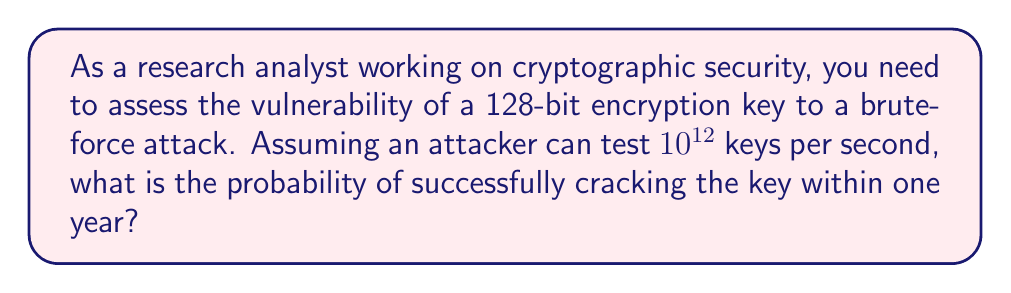Solve this math problem. To solve this problem, we'll follow these steps:

1) First, calculate the total number of possible 128-bit keys:
   $N = 2^{128}$

2) Calculate the number of keys that can be tested in one year:
   Seconds in a year = 365 * 24 * 60 * 60 = 31,536,000
   Keys tested per year = $31,536,000 * 10^{12} = 3.1536 * 10^{19}$

3) The probability of success is the ratio of keys tested to total keys:
   $P = \frac{\text{Keys tested}}{\text{Total keys}} = \frac{3.1536 * 10^{19}}{2^{128}}$

4) Simplify:
   $2^{128} \approx 3.4028 * 10^{38}$
   
   $P = \frac{3.1536 * 10^{19}}{3.4028 * 10^{38}} \approx 9.2676 * 10^{-20}$

5) Convert to scientific notation with 3 significant figures:
   $P \approx 9.27 * 10^{-20}$

This extremely low probability demonstrates the strength of 128-bit encryption against brute-force attacks.
Answer: $9.27 * 10^{-20}$ 